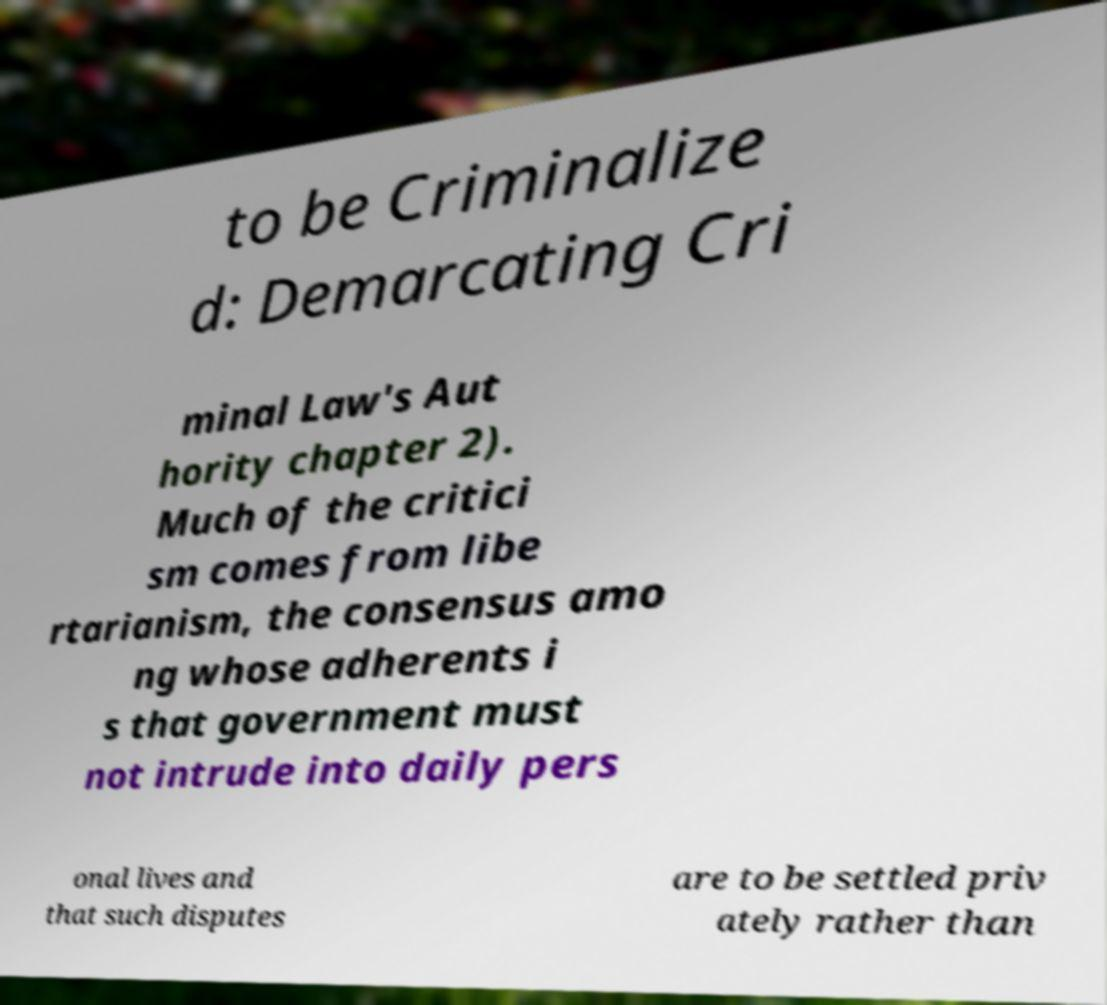For documentation purposes, I need the text within this image transcribed. Could you provide that? to be Criminalize d: Demarcating Cri minal Law's Aut hority chapter 2). Much of the critici sm comes from libe rtarianism, the consensus amo ng whose adherents i s that government must not intrude into daily pers onal lives and that such disputes are to be settled priv ately rather than 